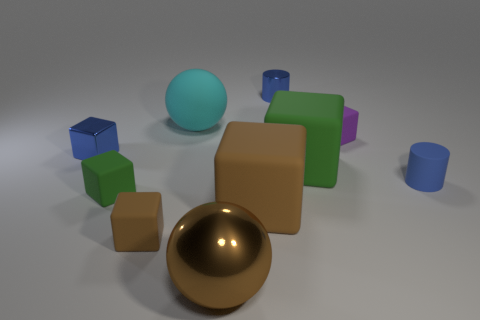Does the metallic block have the same color as the cylinder to the left of the tiny blue matte cylinder?
Make the answer very short. Yes. There is a metallic object that is the same color as the small metallic block; what is its size?
Your response must be concise. Small. What number of matte objects are the same color as the large shiny sphere?
Your answer should be compact. 2. Is the matte cylinder the same color as the tiny shiny block?
Keep it short and to the point. Yes. What is the material of the green thing to the right of the blue shiny cylinder?
Your answer should be compact. Rubber. How many small things are cylinders or rubber balls?
Offer a terse response. 2. There is a small thing that is the same color as the metal ball; what is it made of?
Offer a very short reply. Rubber. Is there a big green block that has the same material as the cyan ball?
Keep it short and to the point. Yes. There is a thing right of the purple matte block; is it the same size as the small purple thing?
Keep it short and to the point. Yes. There is a blue matte thing behind the green matte thing that is left of the big metal sphere; are there any tiny rubber objects that are behind it?
Ensure brevity in your answer.  Yes. 